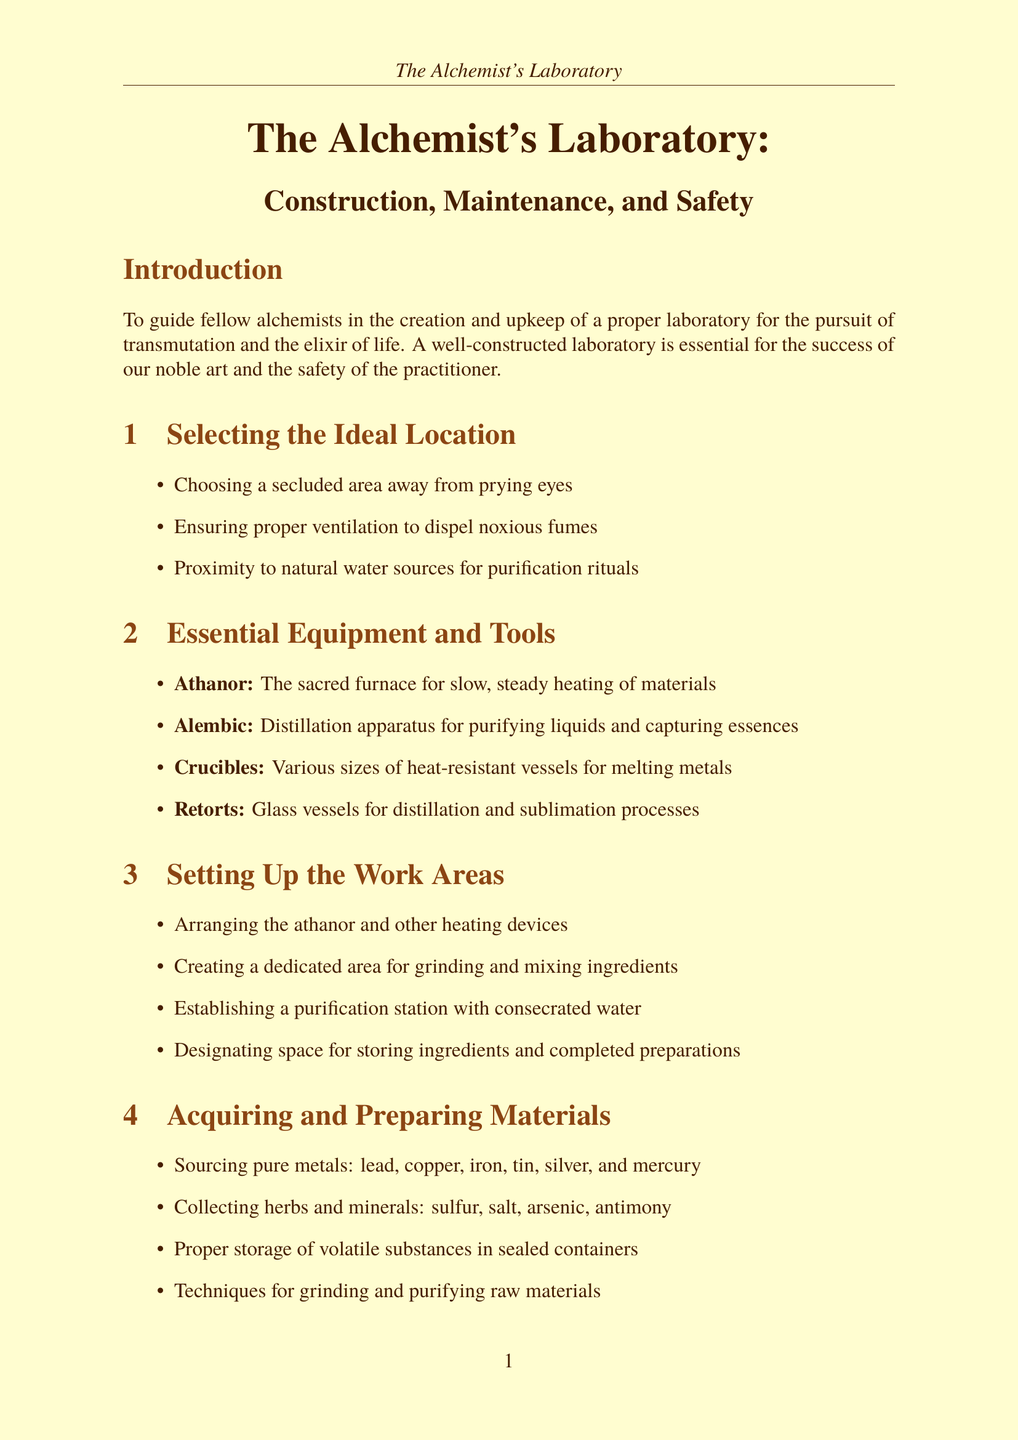What is the purpose of the manual? The purpose of the manual is to guide fellow alchemists in the creation and upkeep of a proper laboratory for the pursuit of transmutation and the elixir of life.
Answer: To guide fellow alchemists What essential equipment includes a furnace? The essential equipment that includes a furnace is called the Athanor.
Answer: Athanor How many sections are in the chapter on Safety Precautions and Protective Measures? The chapter on Safety Precautions and Protective Measures contains four sections listed in the document.
Answer: Four What is one of the materials to source for alchemical work? The document lists several pure metals to source, including lead, copper, iron, tin, silver, and mercury.
Answer: Lead Which device is used for continuous distillation? The device used for continuous distillation is the Pelican.
Answer: Pelican What is a protective garment mentioned in the safety precautions? The manual mentions wearing thick leather aprons and gloves as protective garments.
Answer: Thick leather aprons What type of location should be selected for the laboratory? A proper location should be a secluded area away from prying eyes.
Answer: Secluded area What ritual is performed daily for maintaining the laboratory? Daily rituals include cleansing and consecrating the workspace as part of laboratory maintenance.
Answer: Cleansing and consecrating How should volatile substances be stored? Volatile substances should be stored in sealed containers as stated in the manual.
Answer: Sealed containers 